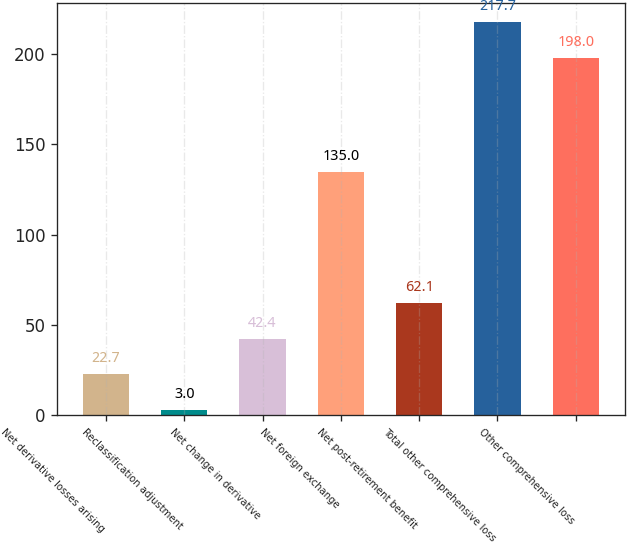Convert chart to OTSL. <chart><loc_0><loc_0><loc_500><loc_500><bar_chart><fcel>Net derivative losses arising<fcel>Reclassification adjustment<fcel>Net change in derivative<fcel>Net foreign exchange<fcel>Net post-retirement benefit<fcel>Total other comprehensive loss<fcel>Other comprehensive loss<nl><fcel>22.7<fcel>3<fcel>42.4<fcel>135<fcel>62.1<fcel>217.7<fcel>198<nl></chart> 